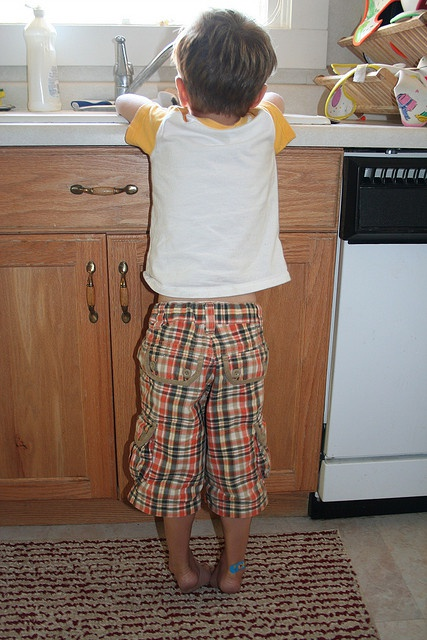Describe the objects in this image and their specific colors. I can see people in white, lightgray, gray, brown, and maroon tones, bottle in white, lightgray, and darkgray tones, and sink in white, lightgray, and darkgray tones in this image. 